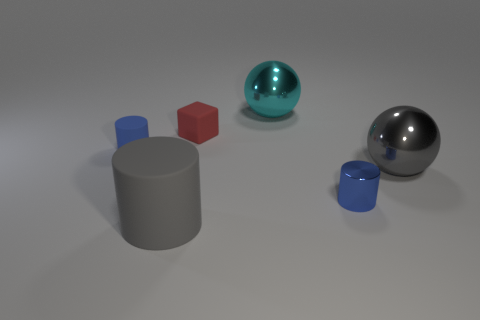Subtract all blue rubber cylinders. How many cylinders are left? 2 Subtract all brown balls. How many blue cylinders are left? 2 Add 2 small rubber blocks. How many objects exist? 8 Subtract all spheres. How many objects are left? 4 Subtract all cylinders. Subtract all tiny cyan cylinders. How many objects are left? 3 Add 4 gray cylinders. How many gray cylinders are left? 5 Add 2 red blocks. How many red blocks exist? 3 Subtract 1 gray cylinders. How many objects are left? 5 Subtract all cyan spheres. Subtract all brown cubes. How many spheres are left? 1 